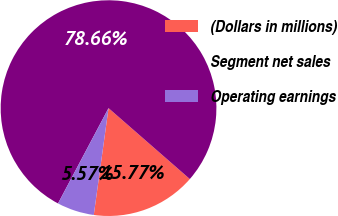Convert chart to OTSL. <chart><loc_0><loc_0><loc_500><loc_500><pie_chart><fcel>(Dollars in millions)<fcel>Segment net sales<fcel>Operating earnings<nl><fcel>15.77%<fcel>78.66%<fcel>5.57%<nl></chart> 